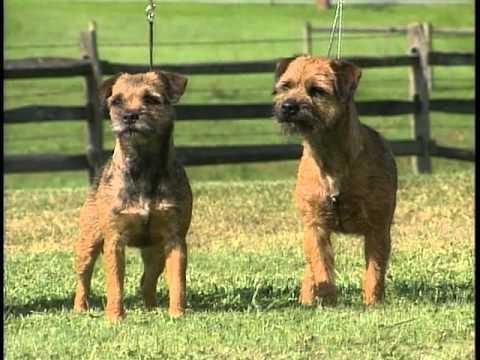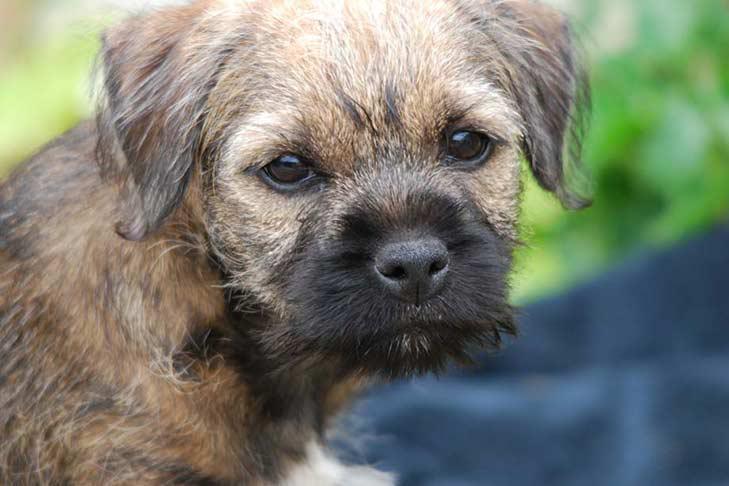The first image is the image on the left, the second image is the image on the right. For the images displayed, is the sentence "The left and right image contains the same number of dogs with at least one sitting in grass." factually correct? Answer yes or no. No. The first image is the image on the left, the second image is the image on the right. For the images displayed, is the sentence "At least two dogs are standing." factually correct? Answer yes or no. Yes. 